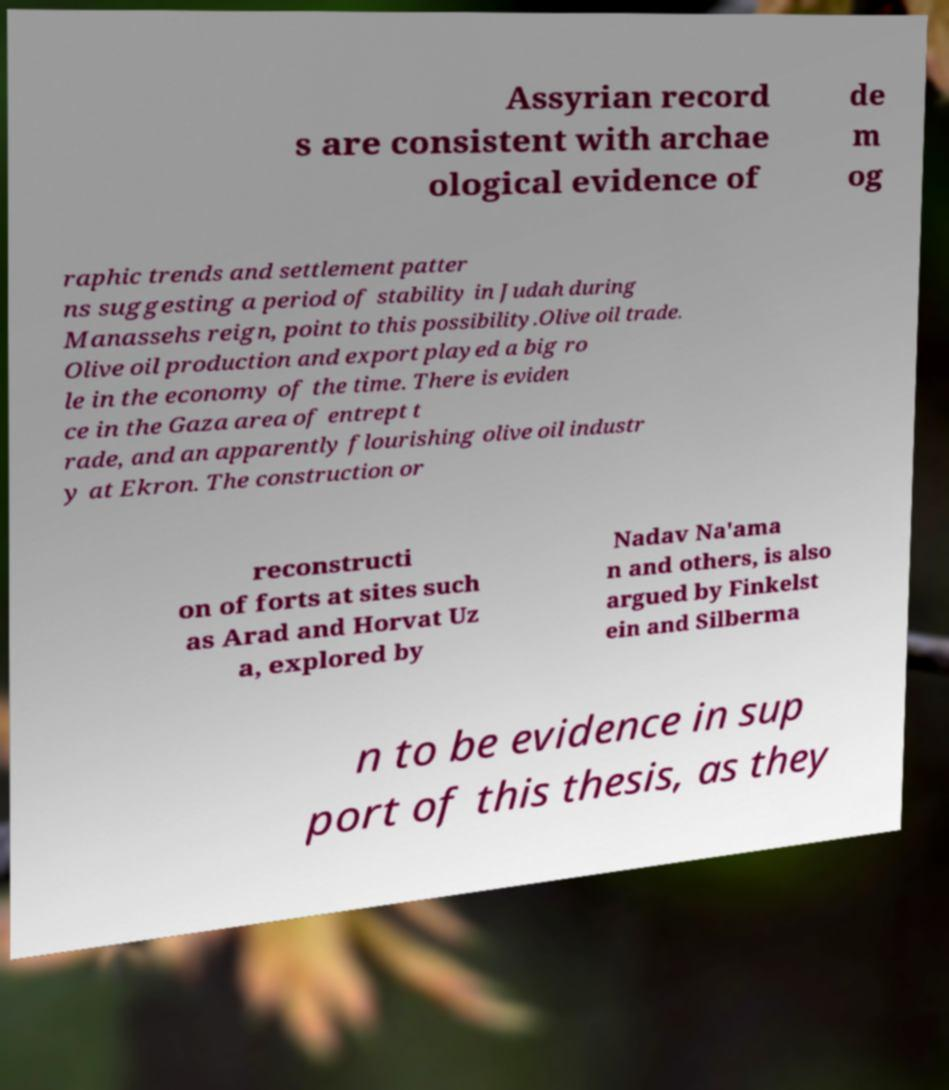For documentation purposes, I need the text within this image transcribed. Could you provide that? Assyrian record s are consistent with archae ological evidence of de m og raphic trends and settlement patter ns suggesting a period of stability in Judah during Manassehs reign, point to this possibility.Olive oil trade. Olive oil production and export played a big ro le in the economy of the time. There is eviden ce in the Gaza area of entrept t rade, and an apparently flourishing olive oil industr y at Ekron. The construction or reconstructi on of forts at sites such as Arad and Horvat Uz a, explored by Nadav Na'ama n and others, is also argued by Finkelst ein and Silberma n to be evidence in sup port of this thesis, as they 